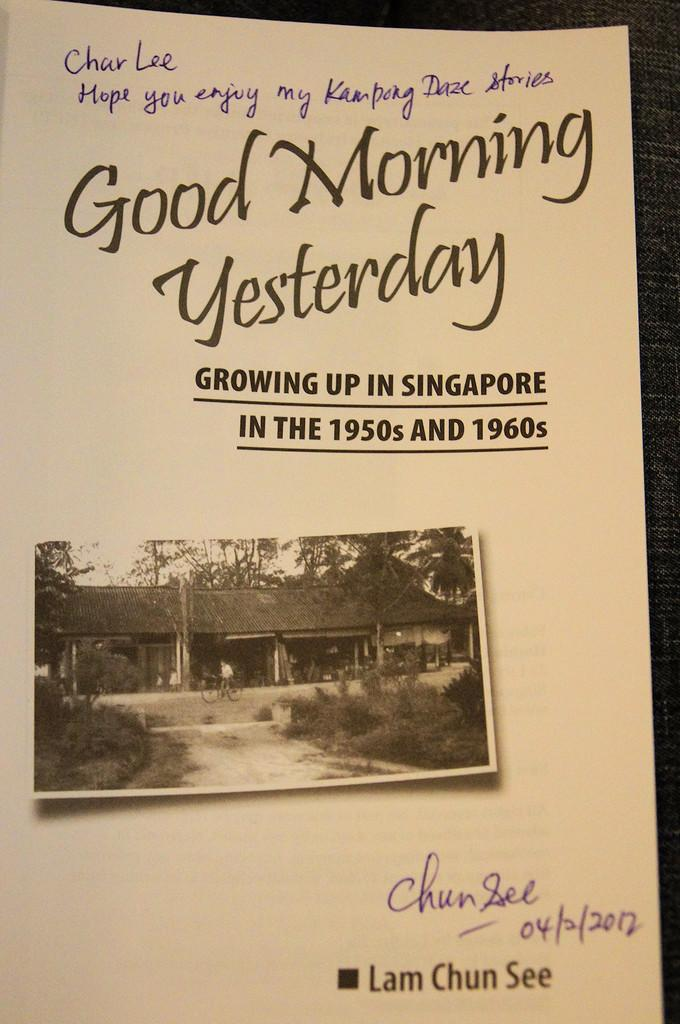<image>
Give a short and clear explanation of the subsequent image. A book is open to the title page that says Good Morning Yesterday. 